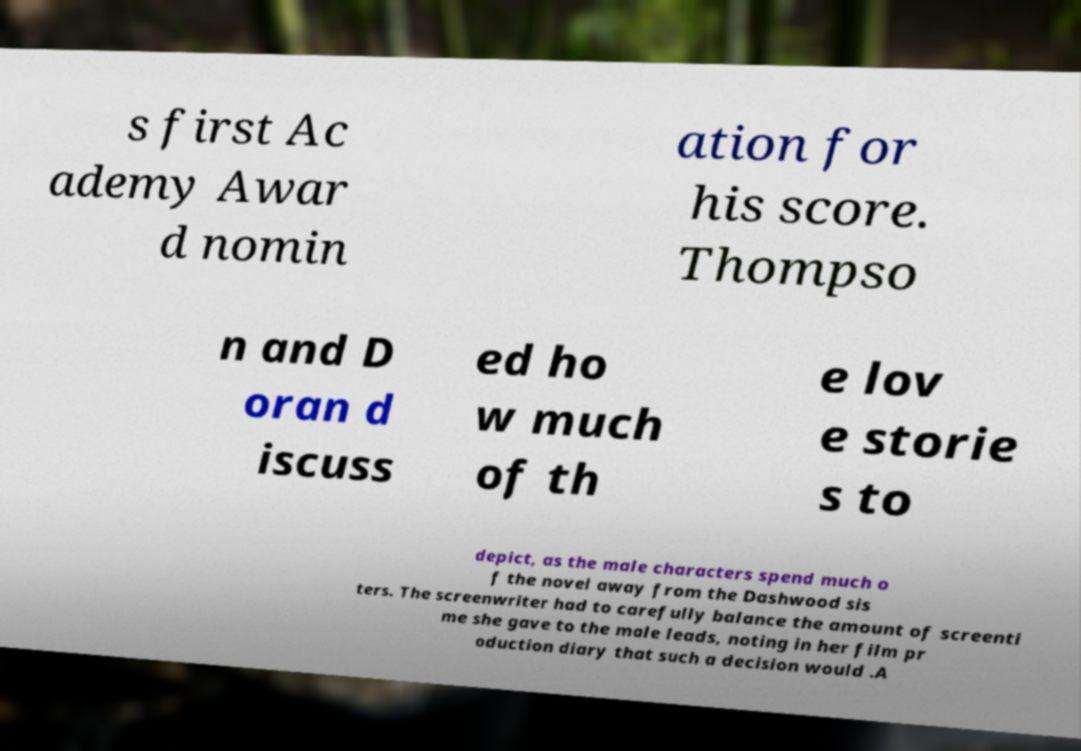Can you accurately transcribe the text from the provided image for me? s first Ac ademy Awar d nomin ation for his score. Thompso n and D oran d iscuss ed ho w much of th e lov e storie s to depict, as the male characters spend much o f the novel away from the Dashwood sis ters. The screenwriter had to carefully balance the amount of screenti me she gave to the male leads, noting in her film pr oduction diary that such a decision would .A 